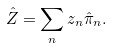<formula> <loc_0><loc_0><loc_500><loc_500>\hat { Z } = \sum _ { n } z _ { n } \hat { \pi } _ { n } .</formula> 